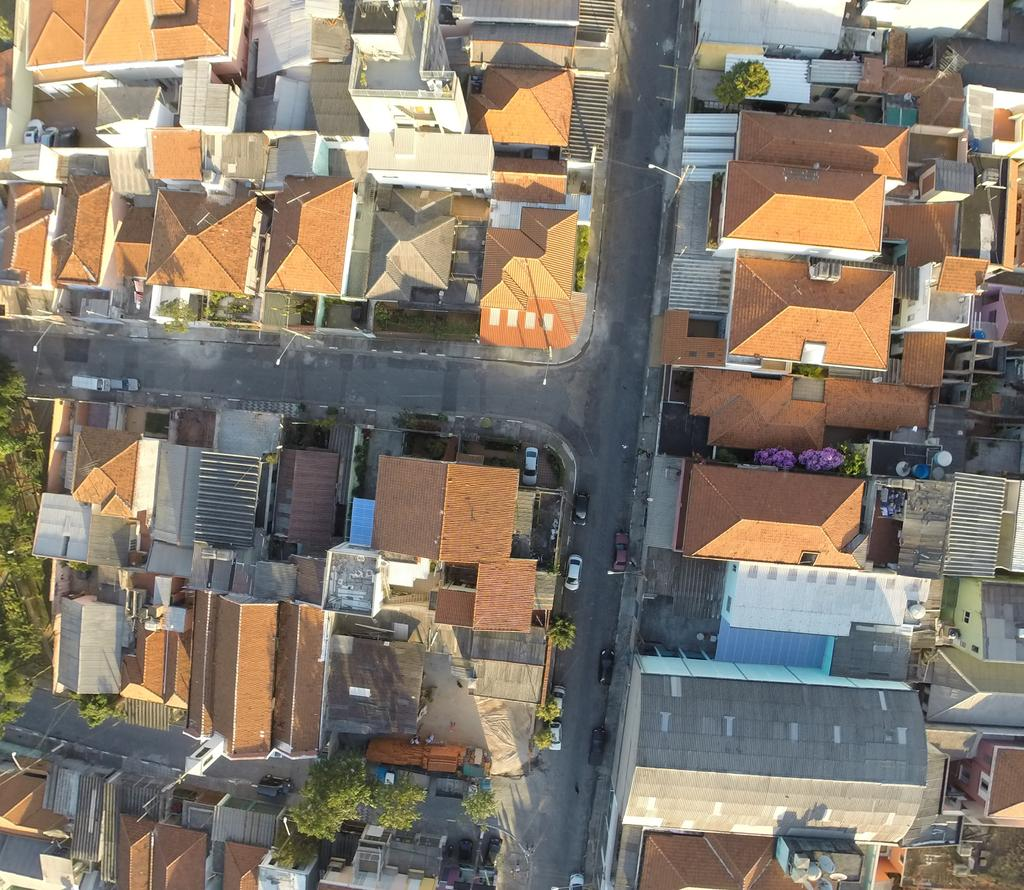What perspective is used in the image? The image is a top view. What type of structures can be seen in the image? There are houses in the image. What else is visible in the image besides houses? There are roads in the image. What can be seen on the left side of the image? There are trees on the left side of the image. What type of brass instrument is being played by the dad in the image? There is no dad or brass instrument present in the image. 